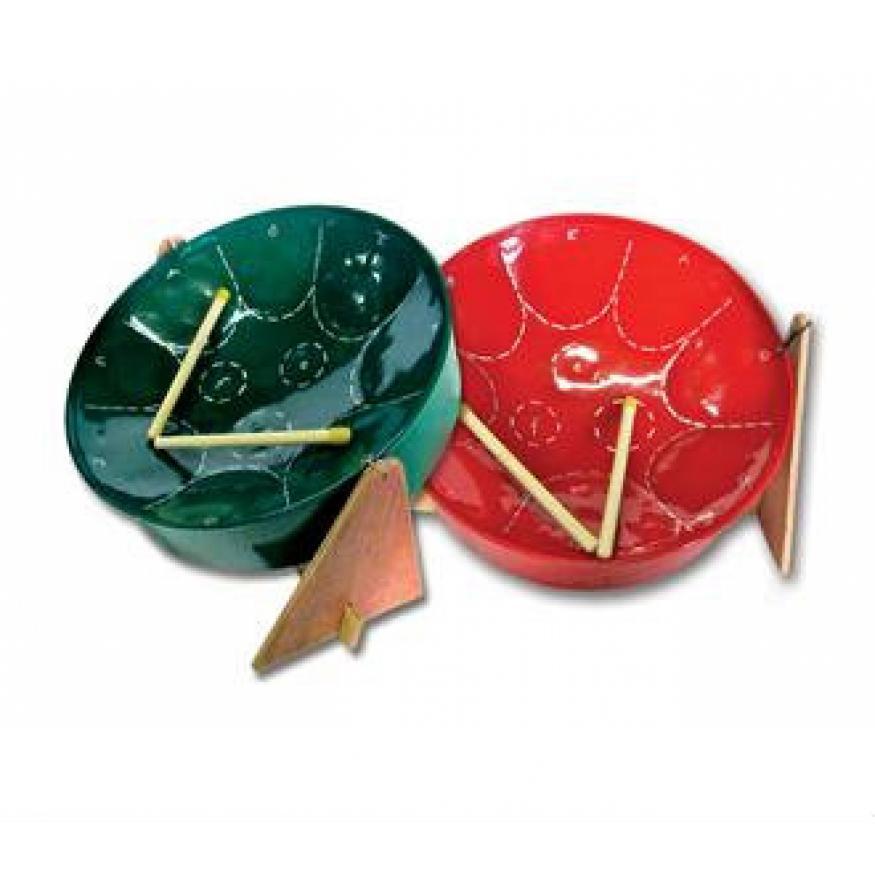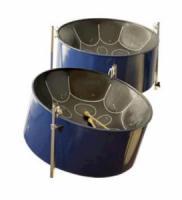The first image is the image on the left, the second image is the image on the right. Considering the images on both sides, is "Each image shows one tilted cylindrical bowl-type drum on a pivoting stand, and the drum on the right has a red exterior and black bowl top." valid? Answer yes or no. No. 